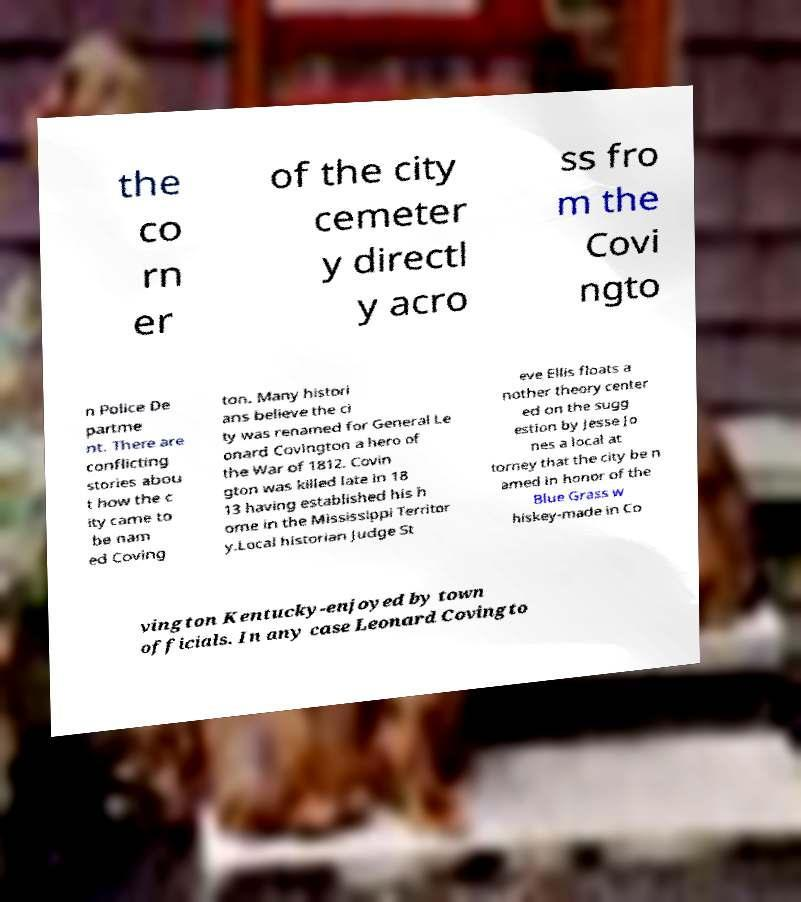Could you extract and type out the text from this image? the co rn er of the city cemeter y directl y acro ss fro m the Covi ngto n Police De partme nt. There are conflicting stories abou t how the c ity came to be nam ed Coving ton. Many histori ans believe the ci ty was renamed for General Le onard Covington a hero of the War of 1812. Covin gton was killed late in 18 13 having established his h ome in the Mississippi Territor y.Local historian Judge St eve Ellis floats a nother theory center ed on the sugg estion by Jesse Jo nes a local at torney that the city be n amed in honor of the Blue Grass w hiskey-made in Co vington Kentucky-enjoyed by town officials. In any case Leonard Covingto 